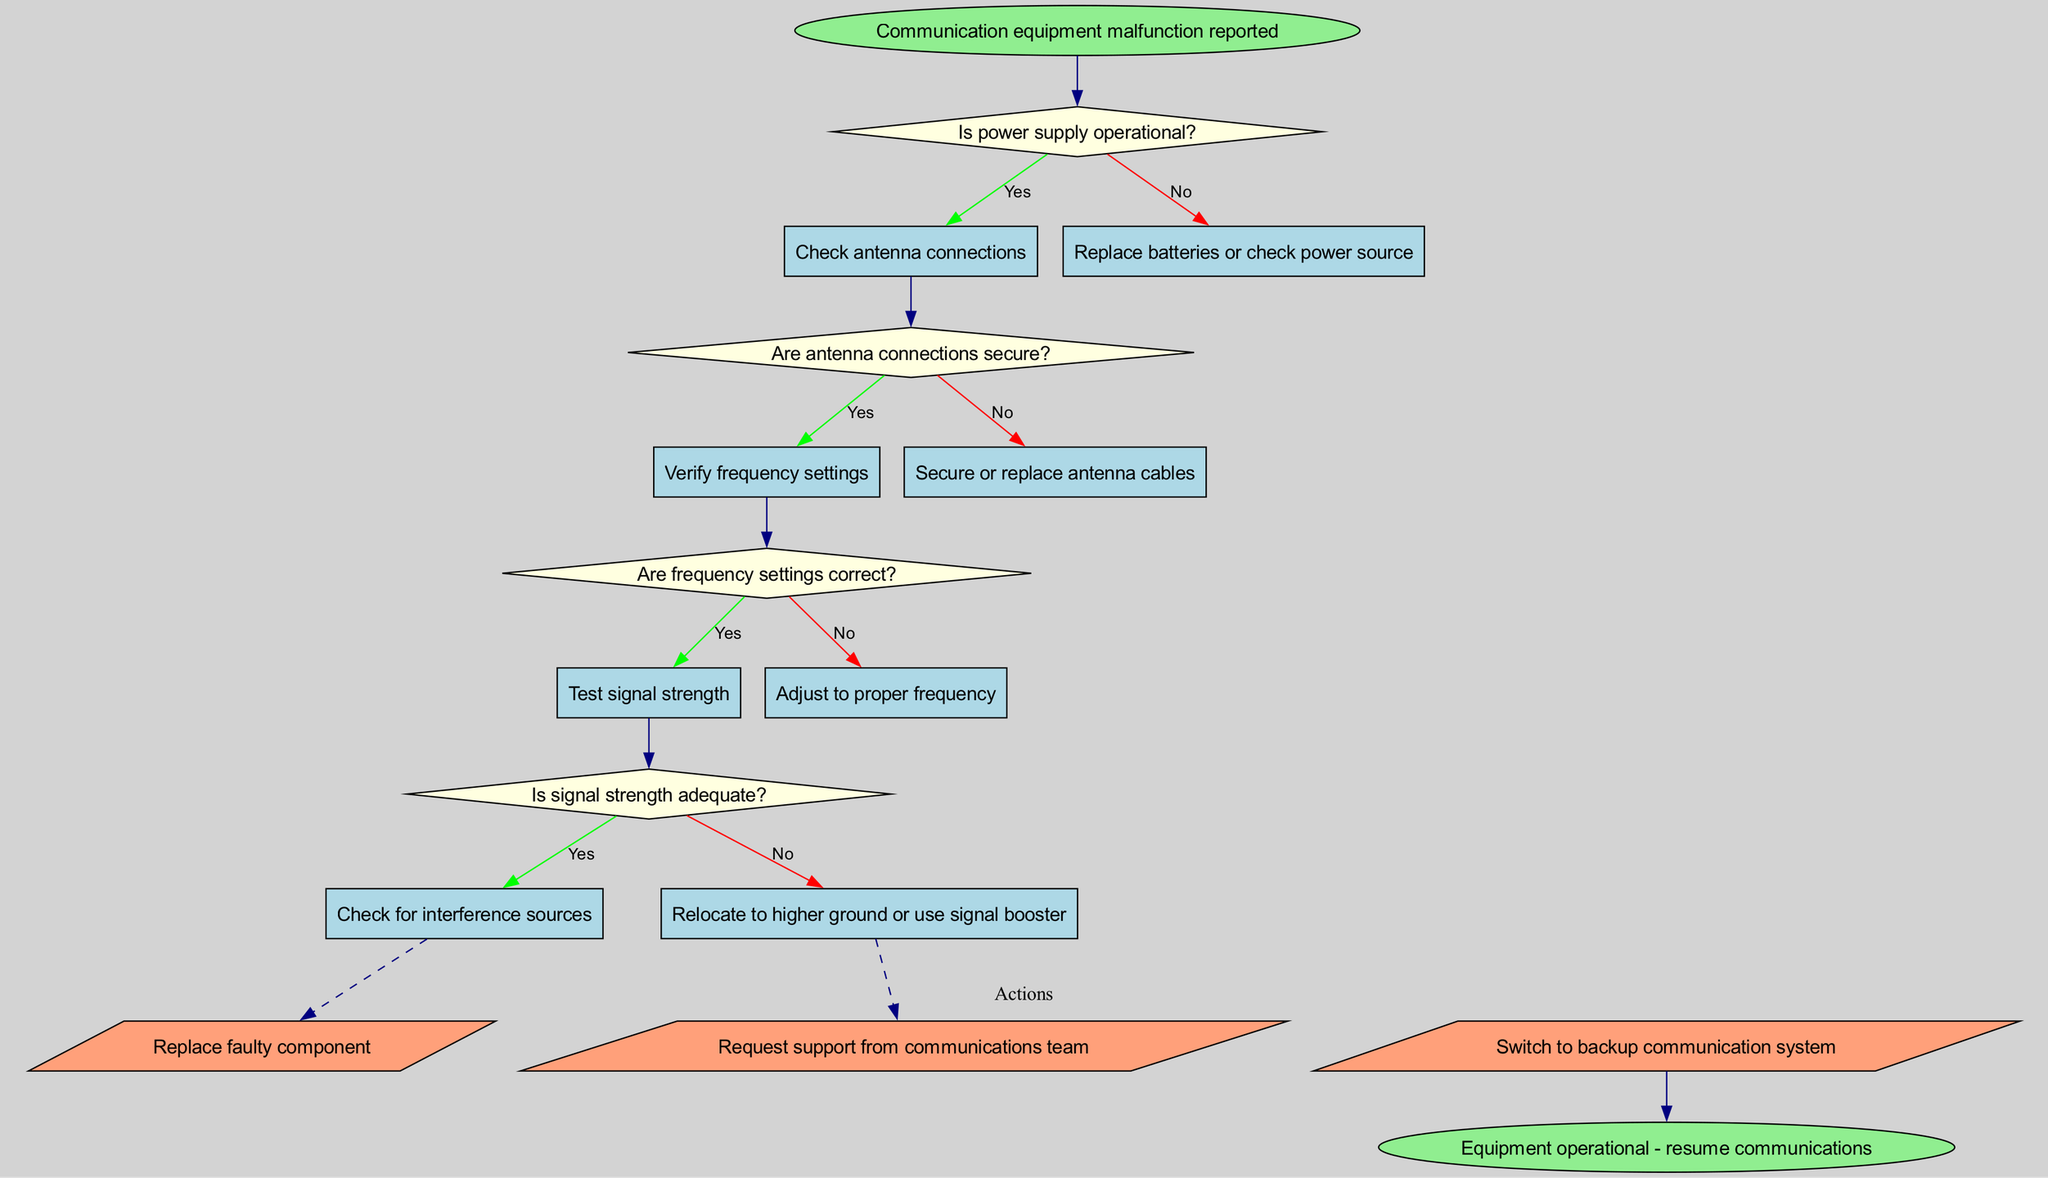What is the starting point of the flow chart? The flow chart starts with the node labeled "Communication equipment malfunction reported," indicating the initial condition for troubleshooting.
Answer: Communication equipment malfunction reported What type of nodes are used for the decisions? The decisions in the flow chart are represented using diamond-shaped nodes, which is typical for indicating a decision point where a yes/no question is asked.
Answer: Diamond How many action nodes are present in the diagram? The diagram contains three action nodes, which are visualized within the actions cluster. Each node represents a possible action to take after a decision is made.
Answer: Three What happens if the power supply is not operational? If the power supply is not operational, the next step is to "Replace batteries or check power source," which is indicated as the result of the "no" decision from the first question in the flow chart.
Answer: Replace batteries or check power source If the frequency settings are correct, what is the next step? If the frequency settings are correct, the next step is to "Test signal strength," based on the flow from the previous decision node analyzing frequency settings.
Answer: Test signal strength What is the output if the signal strength is adequate? If the signal strength is adequate, the following step is to "Check for interference sources," which means the system looks for factors that might affect communication despite a strong signal.
Answer: Check for interference sources How does one proceed if the antenna connections are secure? If the antenna connections are secure, the next action is to "Verify frequency settings," as indicated in the flow for that particular decision.
Answer: Verify frequency settings What is the end result of the troubleshooting process? The end result of the troubleshooting process is indicated by the final node, stating that the equipment is operational and communications can resume as a result of successfully resolving issues.
Answer: Equipment operational - resume communications What would be the action taken if the signal strength is not adequate? If the signal strength is not adequate, the suggested action is to "Relocate to higher ground or use signal booster," which is the next step indicated by the "no" decision from the signal strength check.
Answer: Relocate to higher ground or use signal booster 